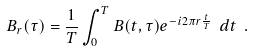Convert formula to latex. <formula><loc_0><loc_0><loc_500><loc_500>B _ { r } ( \tau ) = \frac { 1 } { T } \int ^ { T } _ { 0 } B ( t , \tau ) e ^ { - i 2 \pi r \frac { t } { T } } \ d t \ .</formula> 